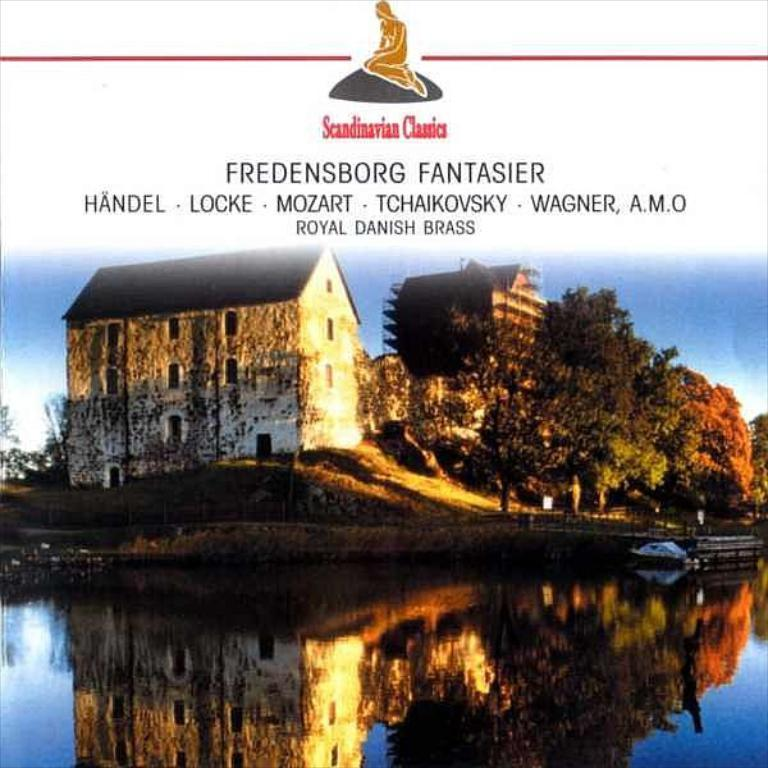What is the main subject in the center of the image? There is water in the center of the image. What can be seen in the background of the image? There are buildings and trees in the background of the image. Is there any text written on the image? Yes, there is text written on the image. What type of vegetation is present on the ground in the image? There is grass on the ground in the image. How many oranges are hanging from the trees in the image? There are no oranges present in the image; it features water, buildings, trees, text, and grass. What type of spark can be seen coming from the wrench in the image? There is no wrench present in the image, so it is not possible to determine if there is a spark or not. 